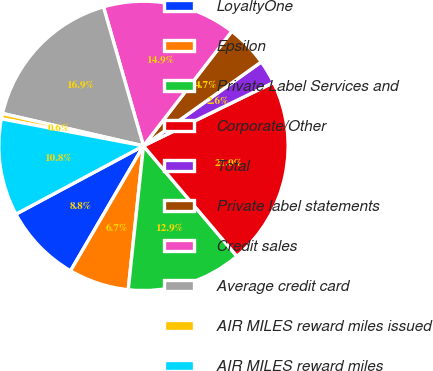Convert chart to OTSL. <chart><loc_0><loc_0><loc_500><loc_500><pie_chart><fcel>LoyaltyOne<fcel>Epsilon<fcel>Private Label Services and<fcel>Corporate/Other<fcel>Total<fcel>Private label statements<fcel>Credit sales<fcel>Average credit card<fcel>AIR MILES reward miles issued<fcel>AIR MILES reward miles<nl><fcel>8.77%<fcel>6.73%<fcel>12.86%<fcel>21.04%<fcel>2.64%<fcel>4.69%<fcel>14.91%<fcel>16.95%<fcel>0.6%<fcel>10.82%<nl></chart> 